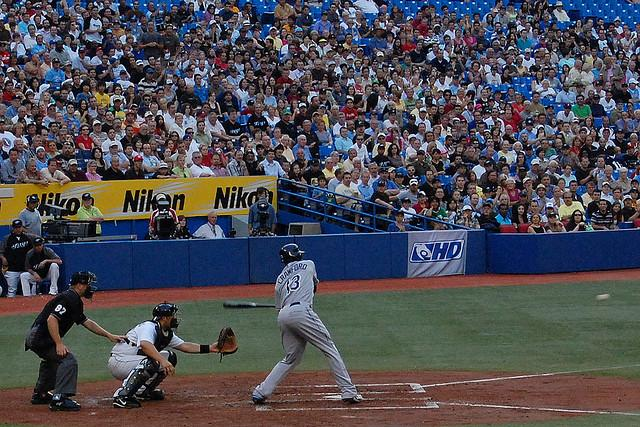The player swinging has the same dominant hand as what person? catcher 